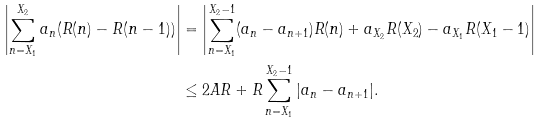<formula> <loc_0><loc_0><loc_500><loc_500>\left | \sum _ { n = X _ { 1 } } ^ { X _ { 2 } } a _ { n } ( R ( n ) - R ( n - 1 ) ) \right | & = \left | \sum _ { n = X _ { 1 } } ^ { X _ { 2 } - 1 } ( a _ { n } - a _ { n + 1 } ) R ( n ) + a _ { X _ { 2 } } R ( X _ { 2 } ) - a _ { X _ { 1 } } R ( X _ { 1 } - 1 ) \right | \\ & \leq 2 A R + R \sum _ { n = X _ { 1 } } ^ { X _ { 2 } - 1 } | a _ { n } - a _ { n + 1 } | .</formula> 